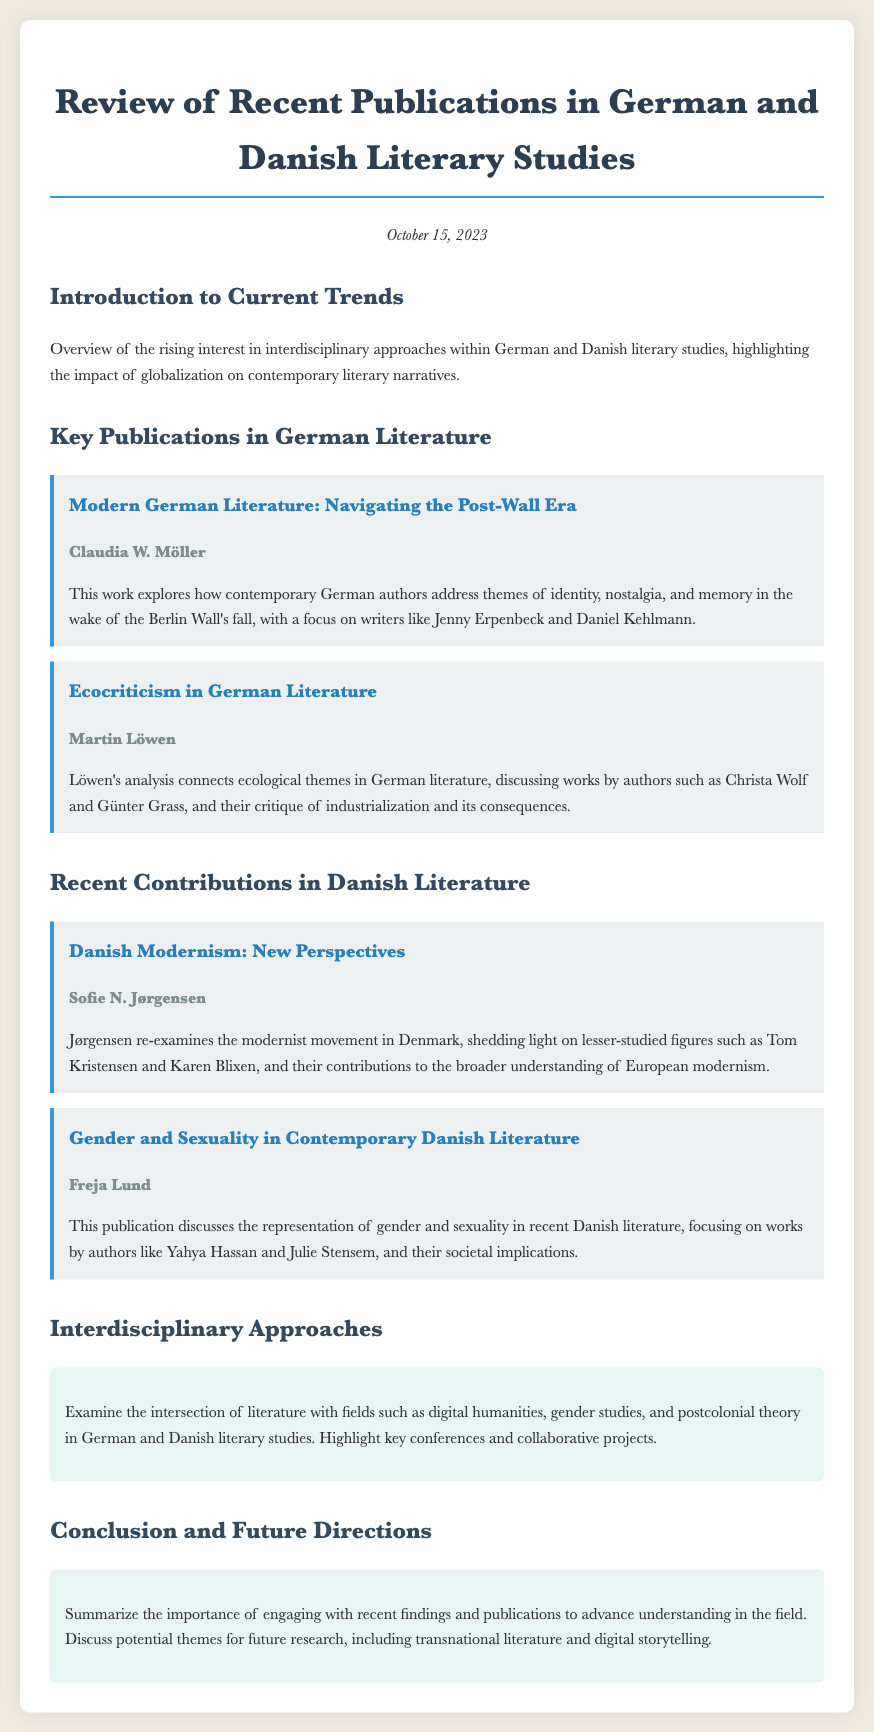What is the date of the document? The date of the document is stated at the top and reads "October 15, 2023."
Answer: October 15, 2023 Who authored the publication "Modern German Literature: Navigating the Post-Wall Era"? The author of this publication is mentioned directly below the title in the document.
Answer: Claudia W. Möller What theme does Martin Löwen's analysis connect with German literature? The theme is outlined in the summary of Löwen's work, which focuses on ecological concerns.
Answer: Ecological themes Which Danish author is highlighted for contributions to modernism? The author in question is specifically mentioned in relation to new perspectives on the modernist movement.
Answer: Tom Kristensen How does Freja Lund’s publication relate to contemporary Danish literature? The publication discusses representation, a key concept highlighted in Lund's analysis, in recent literature.
Answer: Gender and sexuality What interdisciplinary fields are mentioned in relation to literary studies? The document lists specific fields that intersect with literature, providing a sense of the breadth of study involved.
Answer: Digital humanities, gender studies, and postcolonial theory What is the main focus of the conclusion of the document? The conclusion summarizes the significance of engaging with recent findings, as noted in the last section of the document.
Answer: Importance of engaging with recent findings What future theme is suggested for research in the conclusion? The conclusion contains potential themes for future research, as outlined at the end of the document.
Answer: Transnational literature 